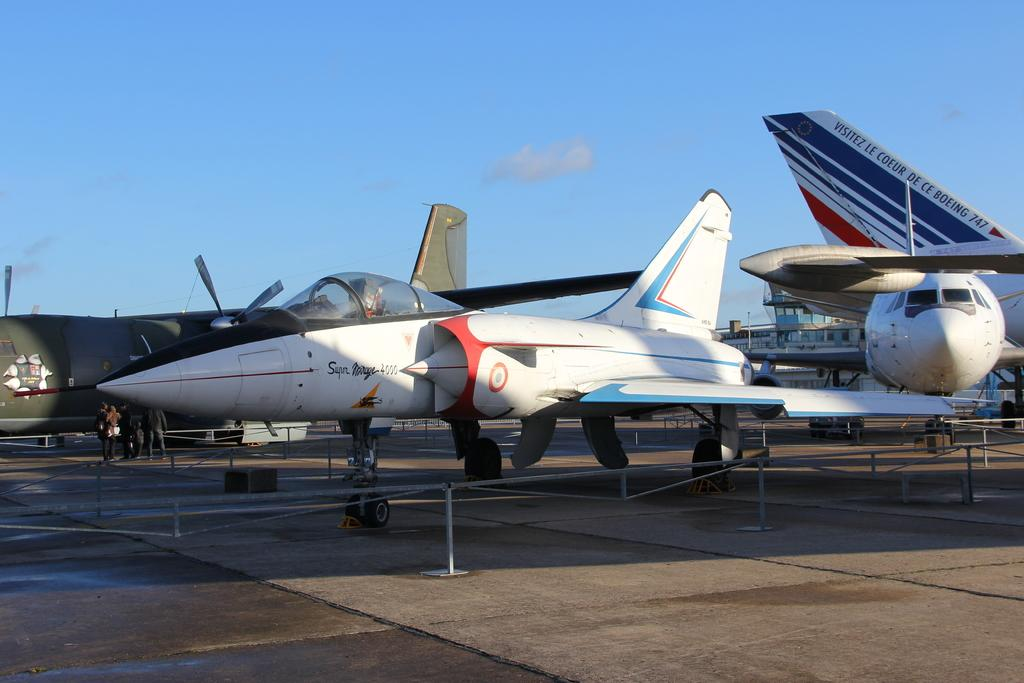<image>
Give a short and clear explanation of the subsequent image. A white plane has the words super mirage on the side. 